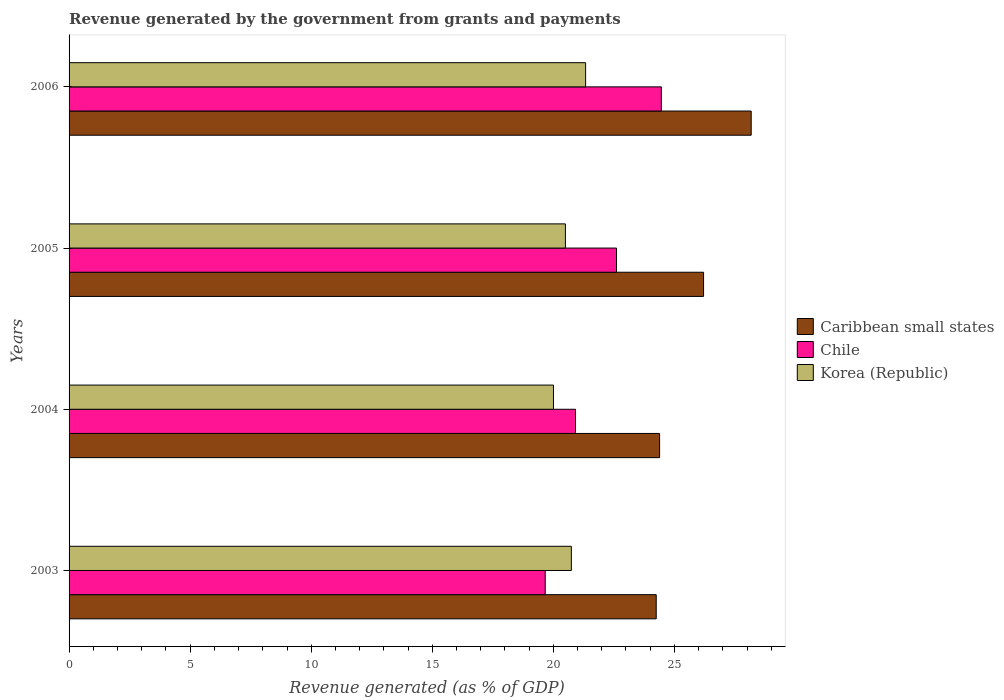How many different coloured bars are there?
Offer a very short reply. 3. Are the number of bars per tick equal to the number of legend labels?
Keep it short and to the point. Yes. In how many cases, is the number of bars for a given year not equal to the number of legend labels?
Give a very brief answer. 0. What is the revenue generated by the government in Caribbean small states in 2005?
Make the answer very short. 26.2. Across all years, what is the maximum revenue generated by the government in Caribbean small states?
Your answer should be very brief. 28.17. Across all years, what is the minimum revenue generated by the government in Korea (Republic)?
Your response must be concise. 20. What is the total revenue generated by the government in Caribbean small states in the graph?
Offer a terse response. 103.01. What is the difference between the revenue generated by the government in Chile in 2004 and that in 2006?
Provide a succinct answer. -3.54. What is the difference between the revenue generated by the government in Korea (Republic) in 2004 and the revenue generated by the government in Chile in 2005?
Your response must be concise. -2.6. What is the average revenue generated by the government in Korea (Republic) per year?
Offer a terse response. 20.64. In the year 2004, what is the difference between the revenue generated by the government in Korea (Republic) and revenue generated by the government in Chile?
Ensure brevity in your answer.  -0.91. What is the ratio of the revenue generated by the government in Caribbean small states in 2003 to that in 2006?
Offer a terse response. 0.86. Is the revenue generated by the government in Chile in 2003 less than that in 2006?
Offer a very short reply. Yes. Is the difference between the revenue generated by the government in Korea (Republic) in 2003 and 2005 greater than the difference between the revenue generated by the government in Chile in 2003 and 2005?
Your answer should be very brief. Yes. What is the difference between the highest and the second highest revenue generated by the government in Chile?
Give a very brief answer. 1.85. What is the difference between the highest and the lowest revenue generated by the government in Caribbean small states?
Offer a very short reply. 3.92. Is the sum of the revenue generated by the government in Caribbean small states in 2003 and 2004 greater than the maximum revenue generated by the government in Chile across all years?
Keep it short and to the point. Yes. What does the 1st bar from the top in 2003 represents?
Keep it short and to the point. Korea (Republic). How many bars are there?
Your answer should be compact. 12. Are all the bars in the graph horizontal?
Offer a terse response. Yes. How many years are there in the graph?
Ensure brevity in your answer.  4. Does the graph contain any zero values?
Offer a very short reply. No. Does the graph contain grids?
Keep it short and to the point. No. Where does the legend appear in the graph?
Your answer should be very brief. Center right. What is the title of the graph?
Offer a terse response. Revenue generated by the government from grants and payments. What is the label or title of the X-axis?
Offer a terse response. Revenue generated (as % of GDP). What is the Revenue generated (as % of GDP) in Caribbean small states in 2003?
Make the answer very short. 24.25. What is the Revenue generated (as % of GDP) in Chile in 2003?
Ensure brevity in your answer.  19.66. What is the Revenue generated (as % of GDP) in Korea (Republic) in 2003?
Provide a succinct answer. 20.74. What is the Revenue generated (as % of GDP) in Caribbean small states in 2004?
Offer a very short reply. 24.39. What is the Revenue generated (as % of GDP) in Chile in 2004?
Keep it short and to the point. 20.92. What is the Revenue generated (as % of GDP) in Korea (Republic) in 2004?
Ensure brevity in your answer.  20. What is the Revenue generated (as % of GDP) of Caribbean small states in 2005?
Make the answer very short. 26.2. What is the Revenue generated (as % of GDP) in Chile in 2005?
Provide a succinct answer. 22.61. What is the Revenue generated (as % of GDP) in Korea (Republic) in 2005?
Provide a short and direct response. 20.5. What is the Revenue generated (as % of GDP) in Caribbean small states in 2006?
Provide a short and direct response. 28.17. What is the Revenue generated (as % of GDP) in Chile in 2006?
Your response must be concise. 24.46. What is the Revenue generated (as % of GDP) of Korea (Republic) in 2006?
Your response must be concise. 21.33. Across all years, what is the maximum Revenue generated (as % of GDP) in Caribbean small states?
Make the answer very short. 28.17. Across all years, what is the maximum Revenue generated (as % of GDP) of Chile?
Provide a short and direct response. 24.46. Across all years, what is the maximum Revenue generated (as % of GDP) of Korea (Republic)?
Keep it short and to the point. 21.33. Across all years, what is the minimum Revenue generated (as % of GDP) in Caribbean small states?
Give a very brief answer. 24.25. Across all years, what is the minimum Revenue generated (as % of GDP) of Chile?
Make the answer very short. 19.66. Across all years, what is the minimum Revenue generated (as % of GDP) of Korea (Republic)?
Keep it short and to the point. 20. What is the total Revenue generated (as % of GDP) in Caribbean small states in the graph?
Ensure brevity in your answer.  103.01. What is the total Revenue generated (as % of GDP) in Chile in the graph?
Your response must be concise. 87.65. What is the total Revenue generated (as % of GDP) of Korea (Republic) in the graph?
Offer a very short reply. 82.58. What is the difference between the Revenue generated (as % of GDP) in Caribbean small states in 2003 and that in 2004?
Keep it short and to the point. -0.14. What is the difference between the Revenue generated (as % of GDP) in Chile in 2003 and that in 2004?
Ensure brevity in your answer.  -1.25. What is the difference between the Revenue generated (as % of GDP) of Korea (Republic) in 2003 and that in 2004?
Keep it short and to the point. 0.74. What is the difference between the Revenue generated (as % of GDP) of Caribbean small states in 2003 and that in 2005?
Provide a short and direct response. -1.96. What is the difference between the Revenue generated (as % of GDP) in Chile in 2003 and that in 2005?
Ensure brevity in your answer.  -2.94. What is the difference between the Revenue generated (as % of GDP) in Korea (Republic) in 2003 and that in 2005?
Provide a short and direct response. 0.25. What is the difference between the Revenue generated (as % of GDP) of Caribbean small states in 2003 and that in 2006?
Provide a short and direct response. -3.92. What is the difference between the Revenue generated (as % of GDP) in Chile in 2003 and that in 2006?
Offer a terse response. -4.8. What is the difference between the Revenue generated (as % of GDP) of Korea (Republic) in 2003 and that in 2006?
Your answer should be compact. -0.59. What is the difference between the Revenue generated (as % of GDP) in Caribbean small states in 2004 and that in 2005?
Provide a succinct answer. -1.82. What is the difference between the Revenue generated (as % of GDP) in Chile in 2004 and that in 2005?
Offer a terse response. -1.69. What is the difference between the Revenue generated (as % of GDP) in Korea (Republic) in 2004 and that in 2005?
Offer a terse response. -0.49. What is the difference between the Revenue generated (as % of GDP) of Caribbean small states in 2004 and that in 2006?
Your answer should be compact. -3.78. What is the difference between the Revenue generated (as % of GDP) of Chile in 2004 and that in 2006?
Offer a very short reply. -3.54. What is the difference between the Revenue generated (as % of GDP) of Korea (Republic) in 2004 and that in 2006?
Keep it short and to the point. -1.33. What is the difference between the Revenue generated (as % of GDP) of Caribbean small states in 2005 and that in 2006?
Offer a terse response. -1.97. What is the difference between the Revenue generated (as % of GDP) of Chile in 2005 and that in 2006?
Offer a very short reply. -1.85. What is the difference between the Revenue generated (as % of GDP) in Korea (Republic) in 2005 and that in 2006?
Provide a short and direct response. -0.83. What is the difference between the Revenue generated (as % of GDP) in Caribbean small states in 2003 and the Revenue generated (as % of GDP) in Chile in 2004?
Provide a succinct answer. 3.33. What is the difference between the Revenue generated (as % of GDP) of Caribbean small states in 2003 and the Revenue generated (as % of GDP) of Korea (Republic) in 2004?
Keep it short and to the point. 4.24. What is the difference between the Revenue generated (as % of GDP) of Chile in 2003 and the Revenue generated (as % of GDP) of Korea (Republic) in 2004?
Provide a succinct answer. -0.34. What is the difference between the Revenue generated (as % of GDP) of Caribbean small states in 2003 and the Revenue generated (as % of GDP) of Chile in 2005?
Your answer should be compact. 1.64. What is the difference between the Revenue generated (as % of GDP) in Caribbean small states in 2003 and the Revenue generated (as % of GDP) in Korea (Republic) in 2005?
Offer a terse response. 3.75. What is the difference between the Revenue generated (as % of GDP) of Chile in 2003 and the Revenue generated (as % of GDP) of Korea (Republic) in 2005?
Offer a terse response. -0.83. What is the difference between the Revenue generated (as % of GDP) of Caribbean small states in 2003 and the Revenue generated (as % of GDP) of Chile in 2006?
Give a very brief answer. -0.21. What is the difference between the Revenue generated (as % of GDP) in Caribbean small states in 2003 and the Revenue generated (as % of GDP) in Korea (Republic) in 2006?
Make the answer very short. 2.92. What is the difference between the Revenue generated (as % of GDP) of Chile in 2003 and the Revenue generated (as % of GDP) of Korea (Republic) in 2006?
Provide a short and direct response. -1.67. What is the difference between the Revenue generated (as % of GDP) of Caribbean small states in 2004 and the Revenue generated (as % of GDP) of Chile in 2005?
Give a very brief answer. 1.78. What is the difference between the Revenue generated (as % of GDP) of Caribbean small states in 2004 and the Revenue generated (as % of GDP) of Korea (Republic) in 2005?
Give a very brief answer. 3.89. What is the difference between the Revenue generated (as % of GDP) of Chile in 2004 and the Revenue generated (as % of GDP) of Korea (Republic) in 2005?
Provide a short and direct response. 0.42. What is the difference between the Revenue generated (as % of GDP) of Caribbean small states in 2004 and the Revenue generated (as % of GDP) of Chile in 2006?
Offer a terse response. -0.07. What is the difference between the Revenue generated (as % of GDP) of Caribbean small states in 2004 and the Revenue generated (as % of GDP) of Korea (Republic) in 2006?
Keep it short and to the point. 3.06. What is the difference between the Revenue generated (as % of GDP) in Chile in 2004 and the Revenue generated (as % of GDP) in Korea (Republic) in 2006?
Provide a short and direct response. -0.42. What is the difference between the Revenue generated (as % of GDP) of Caribbean small states in 2005 and the Revenue generated (as % of GDP) of Chile in 2006?
Your answer should be very brief. 1.74. What is the difference between the Revenue generated (as % of GDP) of Caribbean small states in 2005 and the Revenue generated (as % of GDP) of Korea (Republic) in 2006?
Give a very brief answer. 4.87. What is the difference between the Revenue generated (as % of GDP) of Chile in 2005 and the Revenue generated (as % of GDP) of Korea (Republic) in 2006?
Ensure brevity in your answer.  1.28. What is the average Revenue generated (as % of GDP) of Caribbean small states per year?
Your answer should be very brief. 25.75. What is the average Revenue generated (as % of GDP) of Chile per year?
Offer a very short reply. 21.91. What is the average Revenue generated (as % of GDP) in Korea (Republic) per year?
Ensure brevity in your answer.  20.64. In the year 2003, what is the difference between the Revenue generated (as % of GDP) in Caribbean small states and Revenue generated (as % of GDP) in Chile?
Provide a short and direct response. 4.58. In the year 2003, what is the difference between the Revenue generated (as % of GDP) of Caribbean small states and Revenue generated (as % of GDP) of Korea (Republic)?
Ensure brevity in your answer.  3.5. In the year 2003, what is the difference between the Revenue generated (as % of GDP) of Chile and Revenue generated (as % of GDP) of Korea (Republic)?
Offer a very short reply. -1.08. In the year 2004, what is the difference between the Revenue generated (as % of GDP) in Caribbean small states and Revenue generated (as % of GDP) in Chile?
Offer a terse response. 3.47. In the year 2004, what is the difference between the Revenue generated (as % of GDP) in Caribbean small states and Revenue generated (as % of GDP) in Korea (Republic)?
Give a very brief answer. 4.38. In the year 2004, what is the difference between the Revenue generated (as % of GDP) of Chile and Revenue generated (as % of GDP) of Korea (Republic)?
Offer a very short reply. 0.91. In the year 2005, what is the difference between the Revenue generated (as % of GDP) in Caribbean small states and Revenue generated (as % of GDP) in Chile?
Offer a terse response. 3.6. In the year 2005, what is the difference between the Revenue generated (as % of GDP) in Caribbean small states and Revenue generated (as % of GDP) in Korea (Republic)?
Make the answer very short. 5.71. In the year 2005, what is the difference between the Revenue generated (as % of GDP) in Chile and Revenue generated (as % of GDP) in Korea (Republic)?
Make the answer very short. 2.11. In the year 2006, what is the difference between the Revenue generated (as % of GDP) of Caribbean small states and Revenue generated (as % of GDP) of Chile?
Your answer should be compact. 3.71. In the year 2006, what is the difference between the Revenue generated (as % of GDP) in Caribbean small states and Revenue generated (as % of GDP) in Korea (Republic)?
Your answer should be compact. 6.84. In the year 2006, what is the difference between the Revenue generated (as % of GDP) in Chile and Revenue generated (as % of GDP) in Korea (Republic)?
Your answer should be compact. 3.13. What is the ratio of the Revenue generated (as % of GDP) of Chile in 2003 to that in 2004?
Your answer should be very brief. 0.94. What is the ratio of the Revenue generated (as % of GDP) of Korea (Republic) in 2003 to that in 2004?
Make the answer very short. 1.04. What is the ratio of the Revenue generated (as % of GDP) in Caribbean small states in 2003 to that in 2005?
Give a very brief answer. 0.93. What is the ratio of the Revenue generated (as % of GDP) of Chile in 2003 to that in 2005?
Make the answer very short. 0.87. What is the ratio of the Revenue generated (as % of GDP) in Caribbean small states in 2003 to that in 2006?
Make the answer very short. 0.86. What is the ratio of the Revenue generated (as % of GDP) in Chile in 2003 to that in 2006?
Your response must be concise. 0.8. What is the ratio of the Revenue generated (as % of GDP) in Korea (Republic) in 2003 to that in 2006?
Make the answer very short. 0.97. What is the ratio of the Revenue generated (as % of GDP) of Caribbean small states in 2004 to that in 2005?
Provide a succinct answer. 0.93. What is the ratio of the Revenue generated (as % of GDP) in Chile in 2004 to that in 2005?
Keep it short and to the point. 0.93. What is the ratio of the Revenue generated (as % of GDP) of Korea (Republic) in 2004 to that in 2005?
Your answer should be compact. 0.98. What is the ratio of the Revenue generated (as % of GDP) in Caribbean small states in 2004 to that in 2006?
Offer a terse response. 0.87. What is the ratio of the Revenue generated (as % of GDP) of Chile in 2004 to that in 2006?
Your answer should be compact. 0.86. What is the ratio of the Revenue generated (as % of GDP) of Korea (Republic) in 2004 to that in 2006?
Your response must be concise. 0.94. What is the ratio of the Revenue generated (as % of GDP) of Caribbean small states in 2005 to that in 2006?
Provide a short and direct response. 0.93. What is the ratio of the Revenue generated (as % of GDP) in Chile in 2005 to that in 2006?
Your response must be concise. 0.92. What is the ratio of the Revenue generated (as % of GDP) in Korea (Republic) in 2005 to that in 2006?
Offer a very short reply. 0.96. What is the difference between the highest and the second highest Revenue generated (as % of GDP) of Caribbean small states?
Offer a very short reply. 1.97. What is the difference between the highest and the second highest Revenue generated (as % of GDP) of Chile?
Provide a short and direct response. 1.85. What is the difference between the highest and the second highest Revenue generated (as % of GDP) in Korea (Republic)?
Your answer should be compact. 0.59. What is the difference between the highest and the lowest Revenue generated (as % of GDP) of Caribbean small states?
Make the answer very short. 3.92. What is the difference between the highest and the lowest Revenue generated (as % of GDP) in Chile?
Your answer should be very brief. 4.8. What is the difference between the highest and the lowest Revenue generated (as % of GDP) of Korea (Republic)?
Provide a succinct answer. 1.33. 